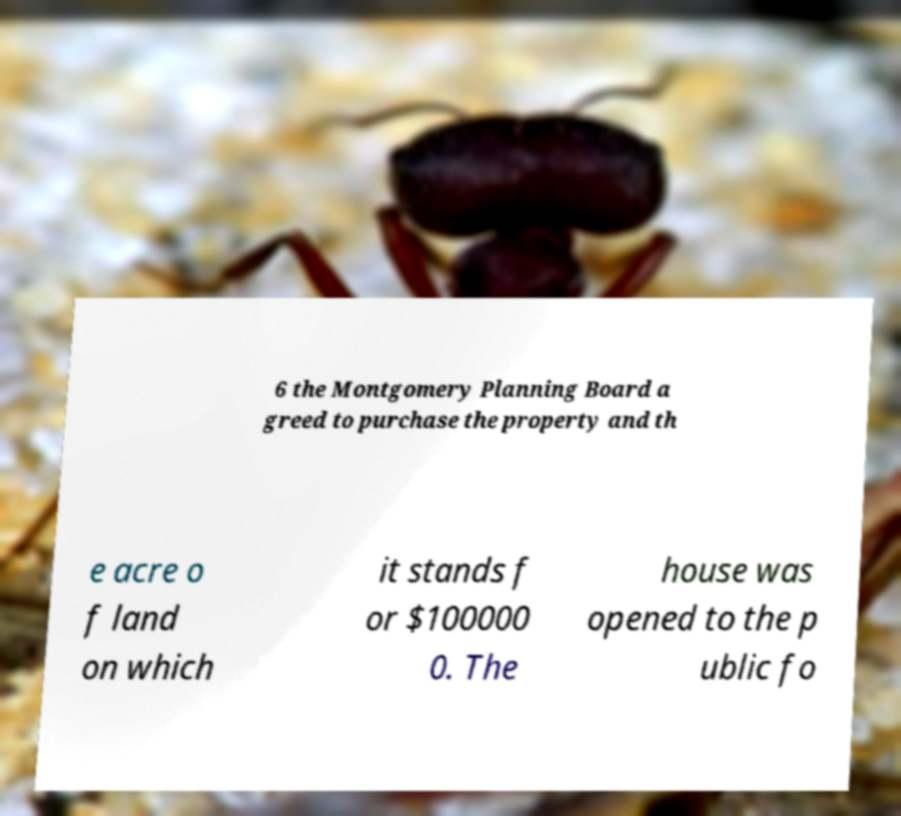Can you accurately transcribe the text from the provided image for me? 6 the Montgomery Planning Board a greed to purchase the property and th e acre o f land on which it stands f or $100000 0. The house was opened to the p ublic fo 